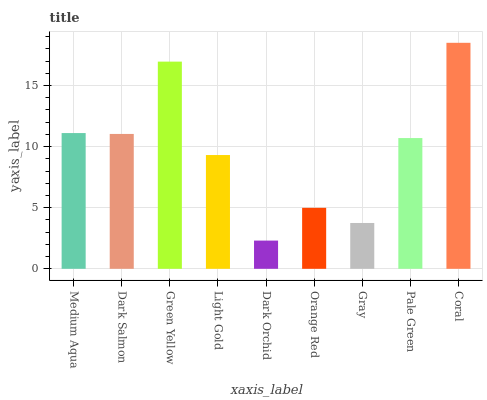Is Dark Orchid the minimum?
Answer yes or no. Yes. Is Coral the maximum?
Answer yes or no. Yes. Is Dark Salmon the minimum?
Answer yes or no. No. Is Dark Salmon the maximum?
Answer yes or no. No. Is Medium Aqua greater than Dark Salmon?
Answer yes or no. Yes. Is Dark Salmon less than Medium Aqua?
Answer yes or no. Yes. Is Dark Salmon greater than Medium Aqua?
Answer yes or no. No. Is Medium Aqua less than Dark Salmon?
Answer yes or no. No. Is Pale Green the high median?
Answer yes or no. Yes. Is Pale Green the low median?
Answer yes or no. Yes. Is Green Yellow the high median?
Answer yes or no. No. Is Dark Orchid the low median?
Answer yes or no. No. 